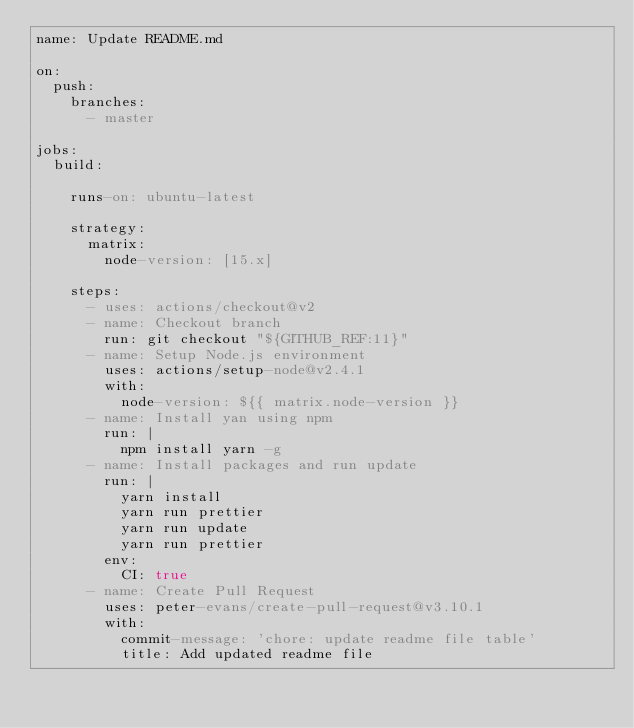Convert code to text. <code><loc_0><loc_0><loc_500><loc_500><_YAML_>name: Update README.md

on:
  push:
    branches:
      - master

jobs:
  build:

    runs-on: ubuntu-latest

    strategy:
      matrix:
        node-version: [15.x]

    steps:
      - uses: actions/checkout@v2
      - name: Checkout branch
        run: git checkout "${GITHUB_REF:11}"
      - name: Setup Node.js environment
        uses: actions/setup-node@v2.4.1
        with:
          node-version: ${{ matrix.node-version }}
      - name: Install yan using npm
        run: |
          npm install yarn -g
      - name: Install packages and run update
        run: |
          yarn install
          yarn run prettier
          yarn run update
          yarn run prettier
        env:
          CI: true
      - name: Create Pull Request
        uses: peter-evans/create-pull-request@v3.10.1
        with:
          commit-message: 'chore: update readme file table'
          title: Add updated readme file
</code> 